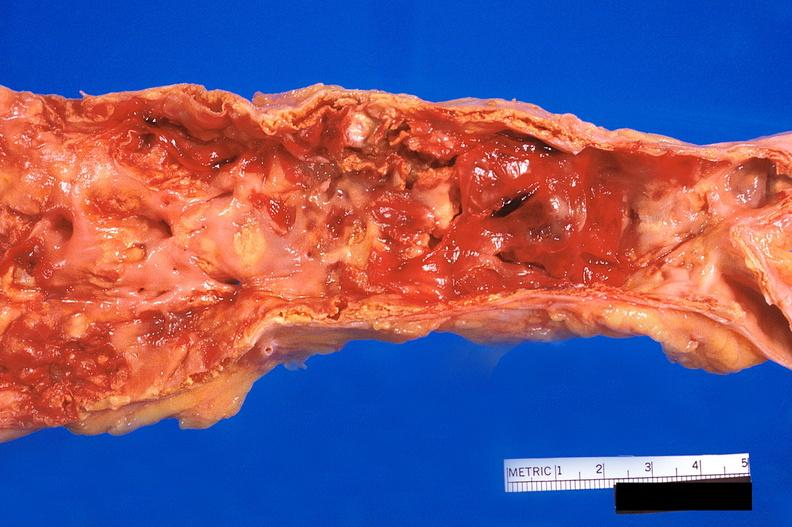where is this?
Answer the question using a single word or phrase. Aorta 